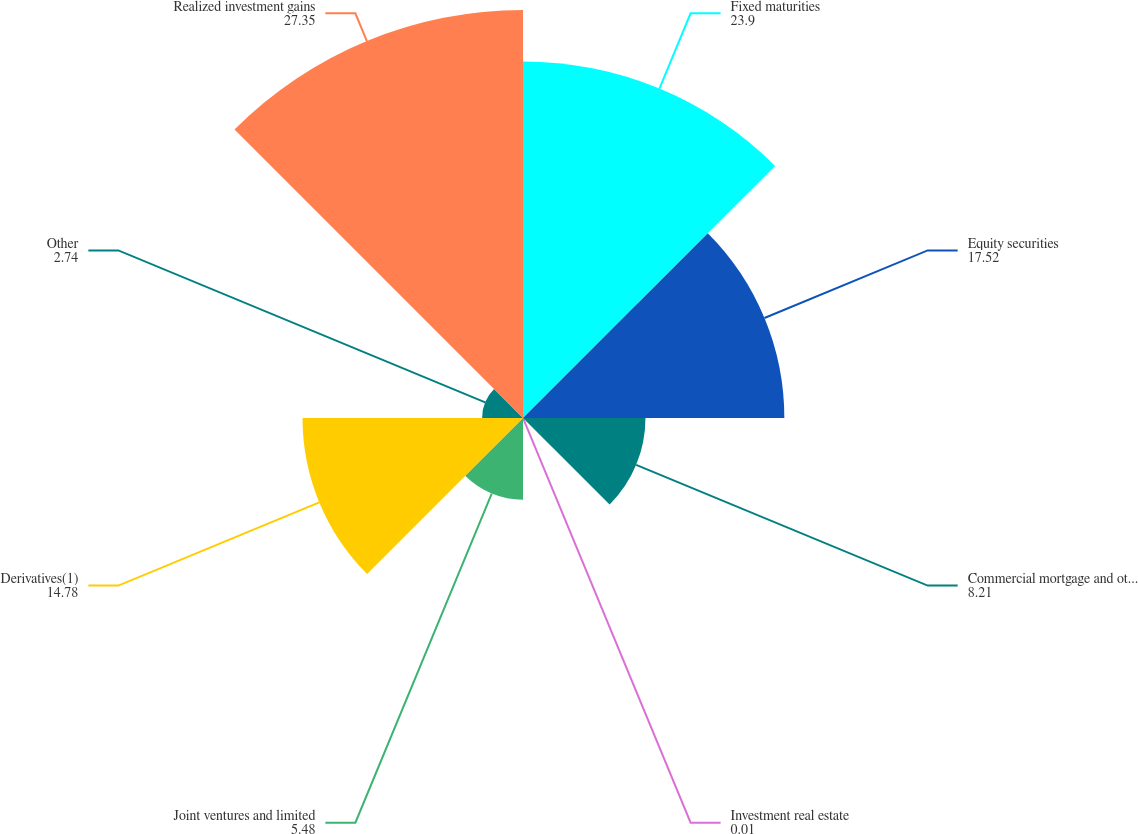Convert chart. <chart><loc_0><loc_0><loc_500><loc_500><pie_chart><fcel>Fixed maturities<fcel>Equity securities<fcel>Commercial mortgage and other<fcel>Investment real estate<fcel>Joint ventures and limited<fcel>Derivatives(1)<fcel>Other<fcel>Realized investment gains<nl><fcel>23.9%<fcel>17.52%<fcel>8.21%<fcel>0.01%<fcel>5.48%<fcel>14.78%<fcel>2.74%<fcel>27.35%<nl></chart> 